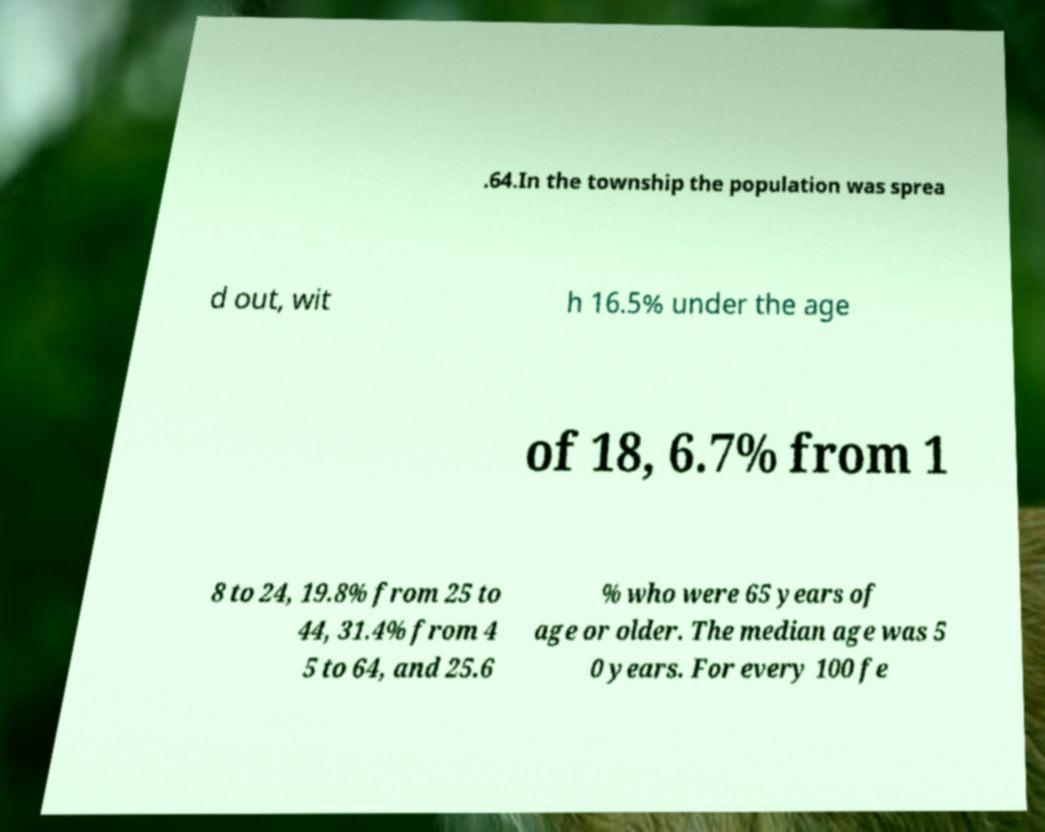Could you extract and type out the text from this image? .64.In the township the population was sprea d out, wit h 16.5% under the age of 18, 6.7% from 1 8 to 24, 19.8% from 25 to 44, 31.4% from 4 5 to 64, and 25.6 % who were 65 years of age or older. The median age was 5 0 years. For every 100 fe 